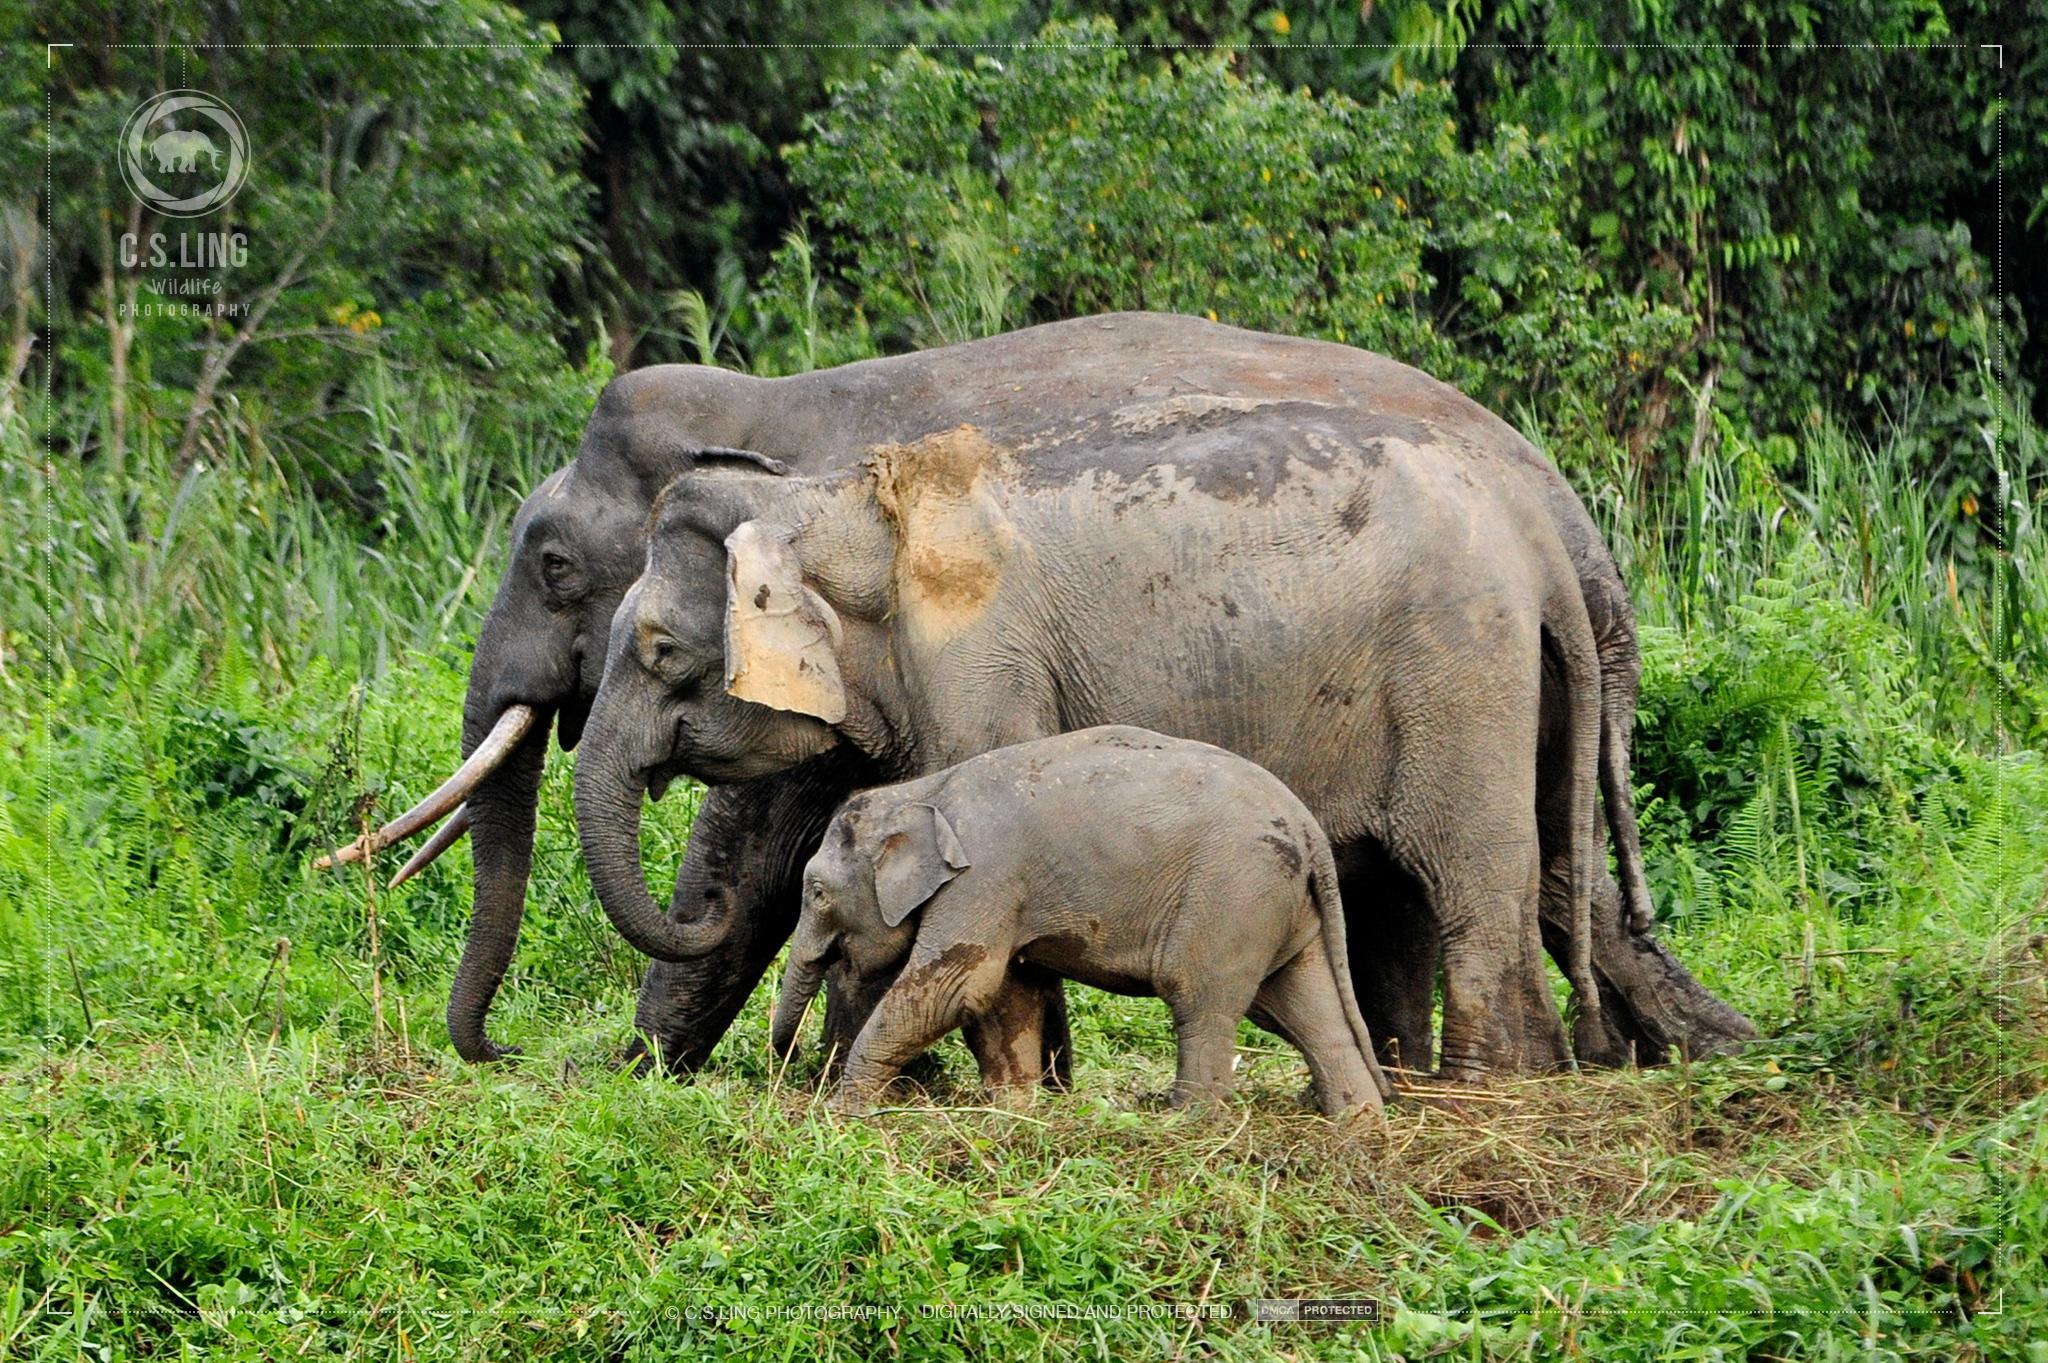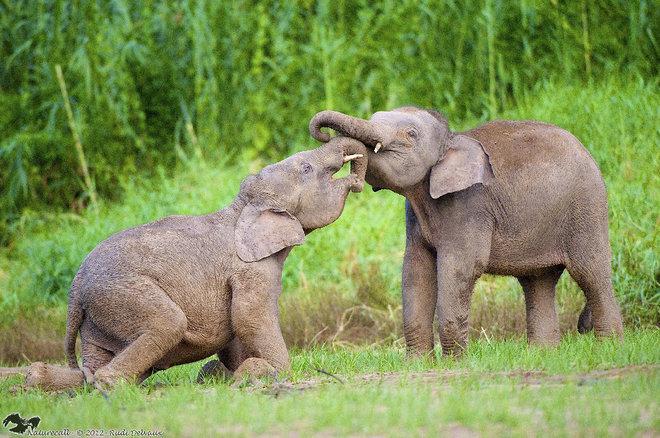The first image is the image on the left, the second image is the image on the right. For the images displayed, is the sentence "There is one elephant in the image on the left with its trunk curled under toward its mouth." factually correct? Answer yes or no. Yes. 